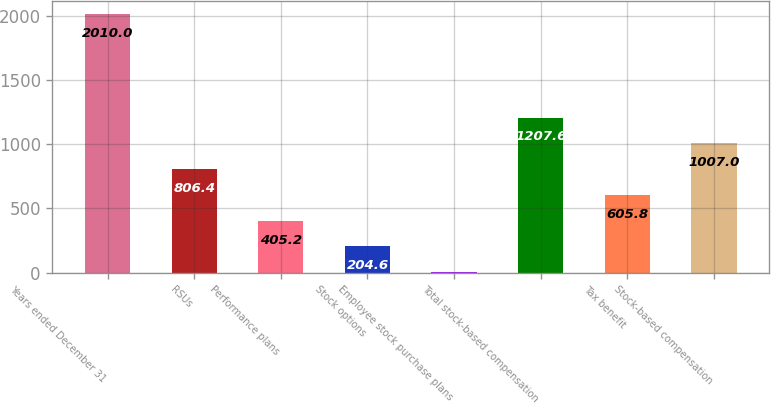Convert chart to OTSL. <chart><loc_0><loc_0><loc_500><loc_500><bar_chart><fcel>Years ended December 31<fcel>RSUs<fcel>Performance plans<fcel>Stock options<fcel>Employee stock purchase plans<fcel>Total stock-based compensation<fcel>Tax benefit<fcel>Stock-based compensation<nl><fcel>2010<fcel>806.4<fcel>405.2<fcel>204.6<fcel>4<fcel>1207.6<fcel>605.8<fcel>1007<nl></chart> 